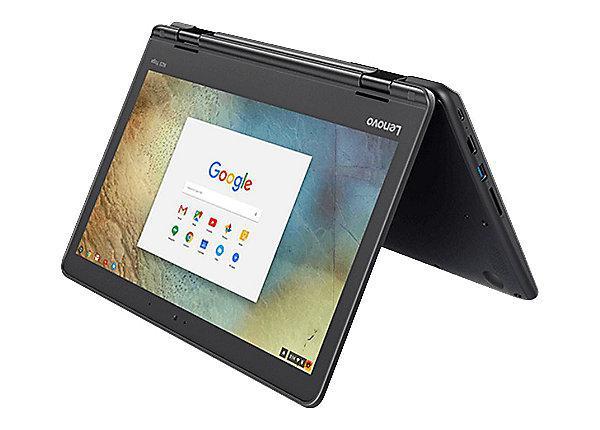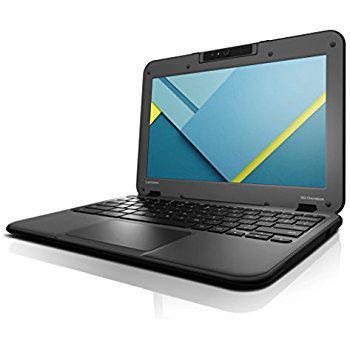The first image is the image on the left, the second image is the image on the right. Assess this claim about the two images: "The combined images include at least three laptops that are open with the screen not inverted.". Correct or not? Answer yes or no. No. The first image is the image on the left, the second image is the image on the right. Evaluate the accuracy of this statement regarding the images: "There are more computers in the image on the left.". Is it true? Answer yes or no. No. 